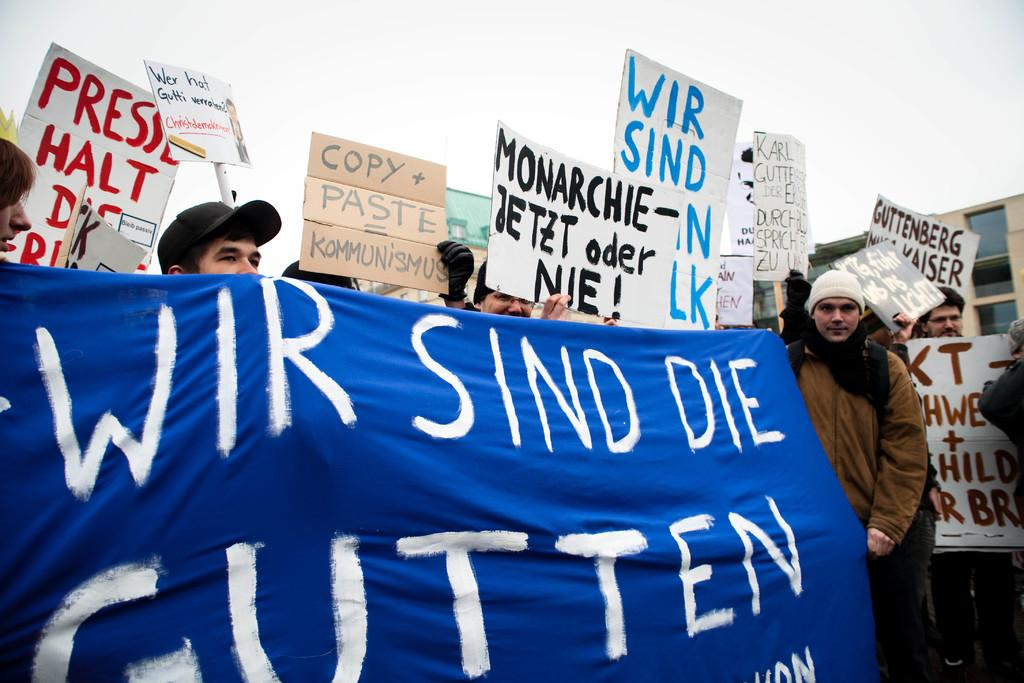What is hanging or displayed in the image? There is a banner in the image. What else can be seen in the image besides the banner? There are boards and people visible in the image. What is visible in the background of the image? There are buildings and the sky visible in the background of the image. What type of flower can be seen growing on the boards in the image? There are no flowers visible in the image, and the boards do not have any plants growing on them. 